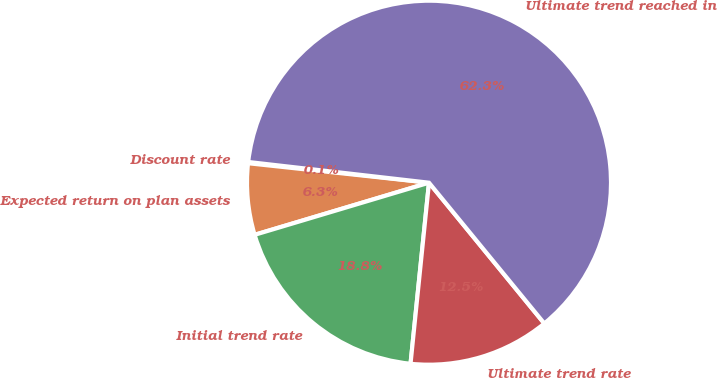Convert chart to OTSL. <chart><loc_0><loc_0><loc_500><loc_500><pie_chart><fcel>Discount rate<fcel>Expected return on plan assets<fcel>Initial trend rate<fcel>Ultimate trend rate<fcel>Ultimate trend reached in<nl><fcel>0.11%<fcel>6.33%<fcel>18.76%<fcel>12.54%<fcel>62.26%<nl></chart> 